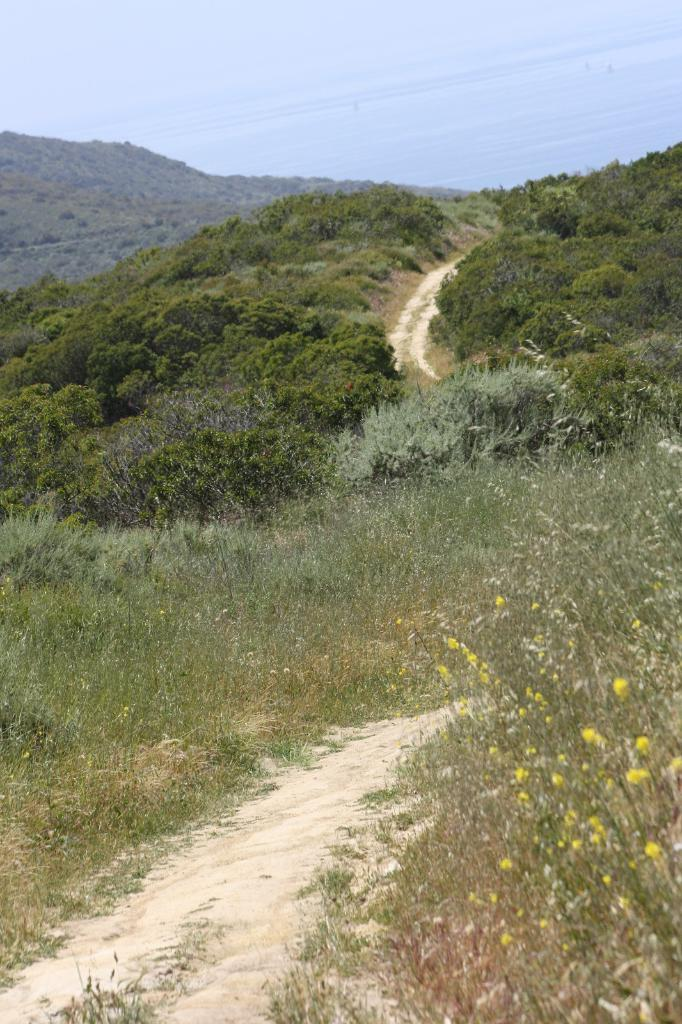What type of vegetation is present on the hill in the image? There are trees on a hill in the image. What type of ground cover can be seen in the image? There is grass on the ground in the image. How would you describe the sky in the image? The sky is blue and cloudy in the image. Where is the cushion placed in the image? There is no cushion present in the image. What type of ray is visible in the image? There is no ray visible in the image. 